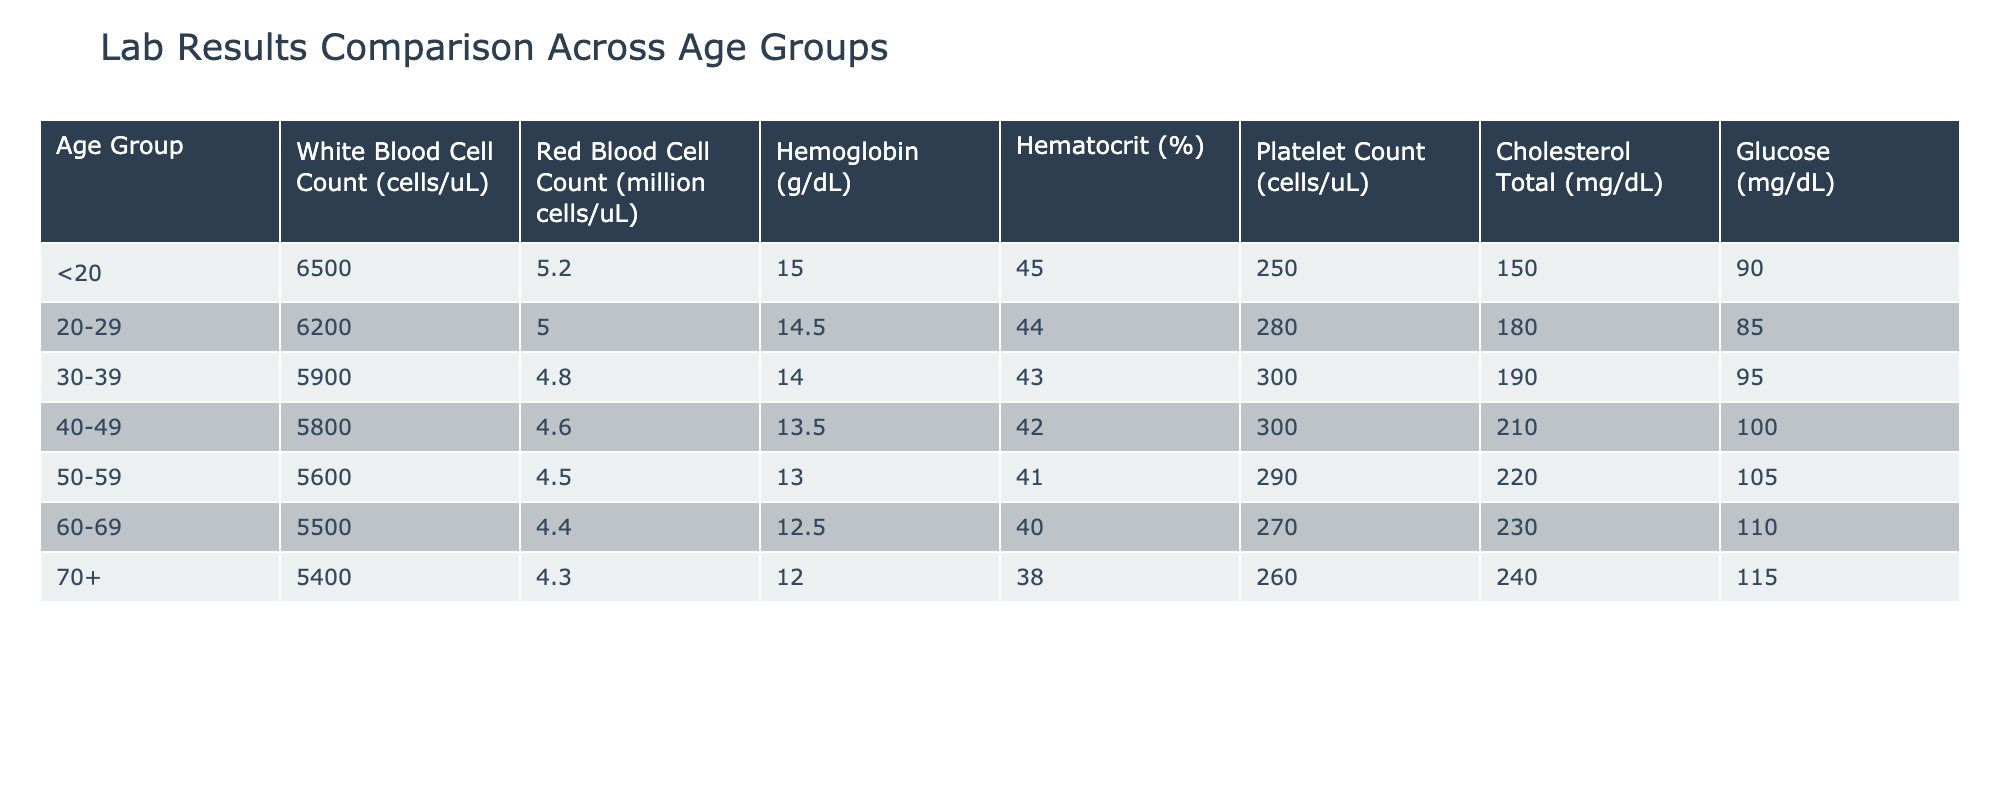What is the White Blood Cell Count for the age group 50-59? The table specifies the White Blood Cell Count for each age group. For the age group 50-59, the value is listed as 5600 cells/uL.
Answer: 5600 cells/uL What is the Hemoglobin level in the age group 30-39? Referring to the table, the Hemoglobin level for the age group 30-39 is directly given as 14.0 g/dL.
Answer: 14.0 g/dL Which age group has the highest Cholesterol Total level? The Cholesterol Total levels are as follows: <20 (250 mg/dL), 20-29 (280 mg/dL), 30-39 (300 mg/dL), 40-49 (300 mg/dL), 50-59 (290 mg/dL), 60-69 (270 mg/dL), 70+ (260 mg/dL). The highest values are both in the 30-39 and 40-49 age groups at 300 mg/dL.
Answer: 30-39 and 40-49 What is the difference in Red Blood Cell Count between the 20-29 and 60-69 age groups? From the table, the Red Blood Cell Count for 20-29 is 5.0 million cells/uL and for 60-69 is 4.4 million cells/uL. The difference is calculated as 5.0 - 4.4 = 0.6 million cells/uL.
Answer: 0.6 million cells/uL Is the Hematocrit percentage for age group 70+ lower than that for age group 20-29? The Hematocrit for 70+ is 38%, while for 20-29 it is 44%. Since 38 is less than 44, the statement is true.
Answer: Yes What is the average Platelet Count across all age groups? To find the average, sum all the Platelet Counts: 250 + 280 + 300 + 300 + 290 + 270 + 260 = 2250. Then divide by the number of age groups, which is 7. So, 2250 / 7 = 321.43 cells/uL.
Answer: 321.43 cells/uL Does the Glucose level for the age group 40-49 exceed the average Glucose for the age group 30-39? The Glucose for 40-49 is 100 mg/dL, while for 30-39 it is 95 mg/dL. Since 100 is greater than 95, this statement is true.
Answer: Yes Which age group has the lowest Red Blood Cell Count? Looking at the table values for Red Blood Cell Count: <20 (5.2), 20-29 (5.0), 30-39 (4.8), 40-49 (4.6), 50-59 (4.5), 60-69 (4.4), and 70+ (4.3), 70+ has the lowest count at 4.3 million cells/uL.
Answer: 70+ 